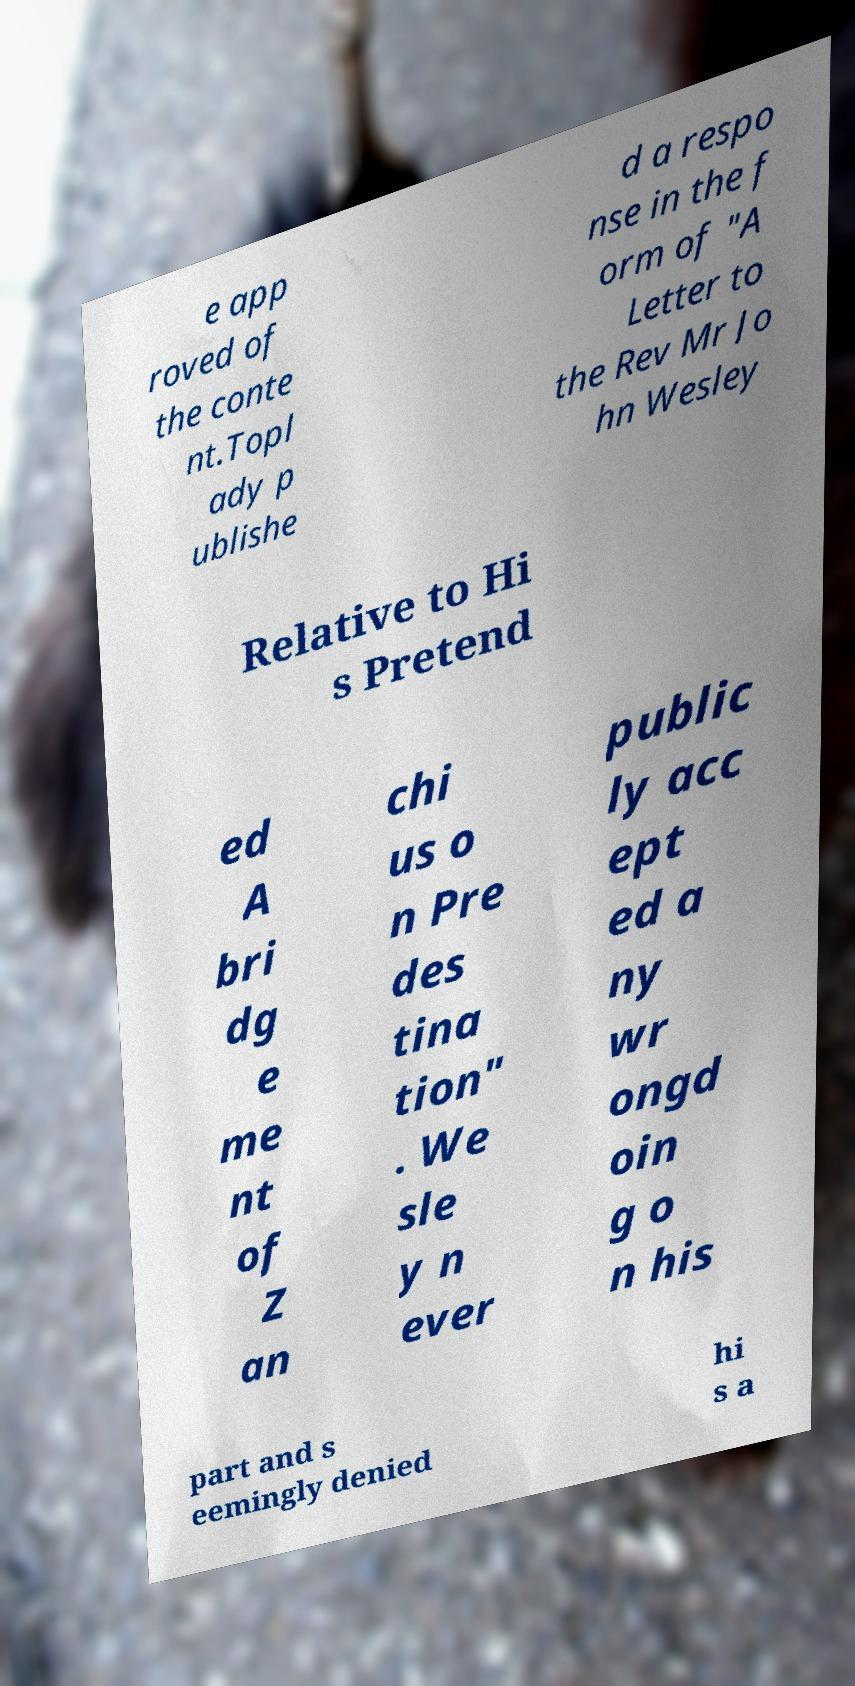There's text embedded in this image that I need extracted. Can you transcribe it verbatim? e app roved of the conte nt.Topl ady p ublishe d a respo nse in the f orm of "A Letter to the Rev Mr Jo hn Wesley Relative to Hi s Pretend ed A bri dg e me nt of Z an chi us o n Pre des tina tion" . We sle y n ever public ly acc ept ed a ny wr ongd oin g o n his part and s eemingly denied hi s a 